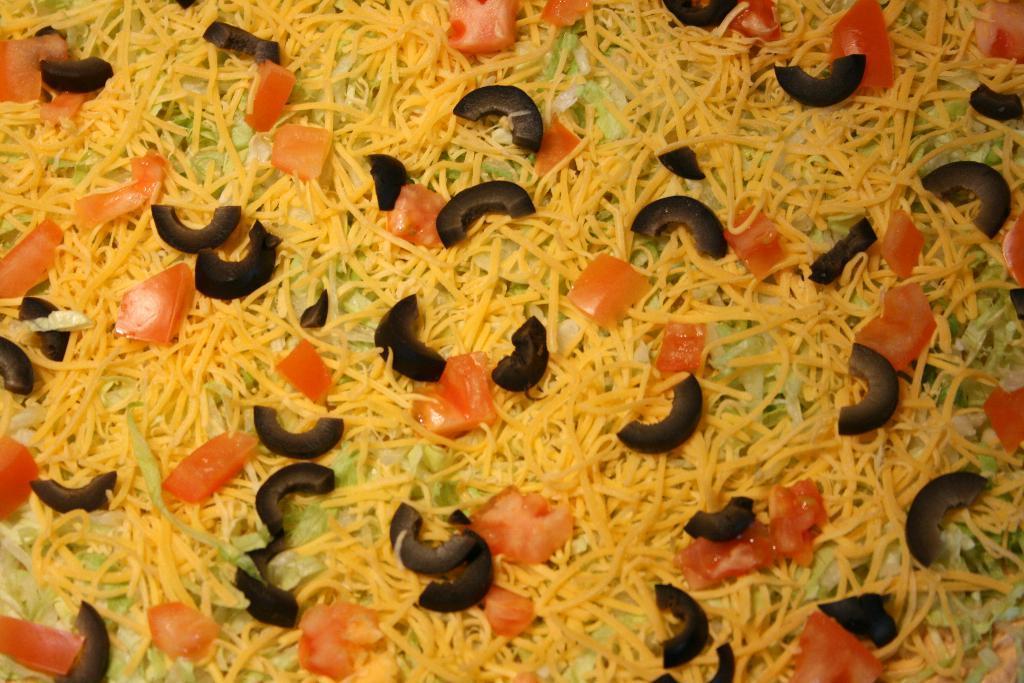How would you summarize this image in a sentence or two? In the center of the image we can see some food items, in which we can see tomato slices and a few other vegetables. 